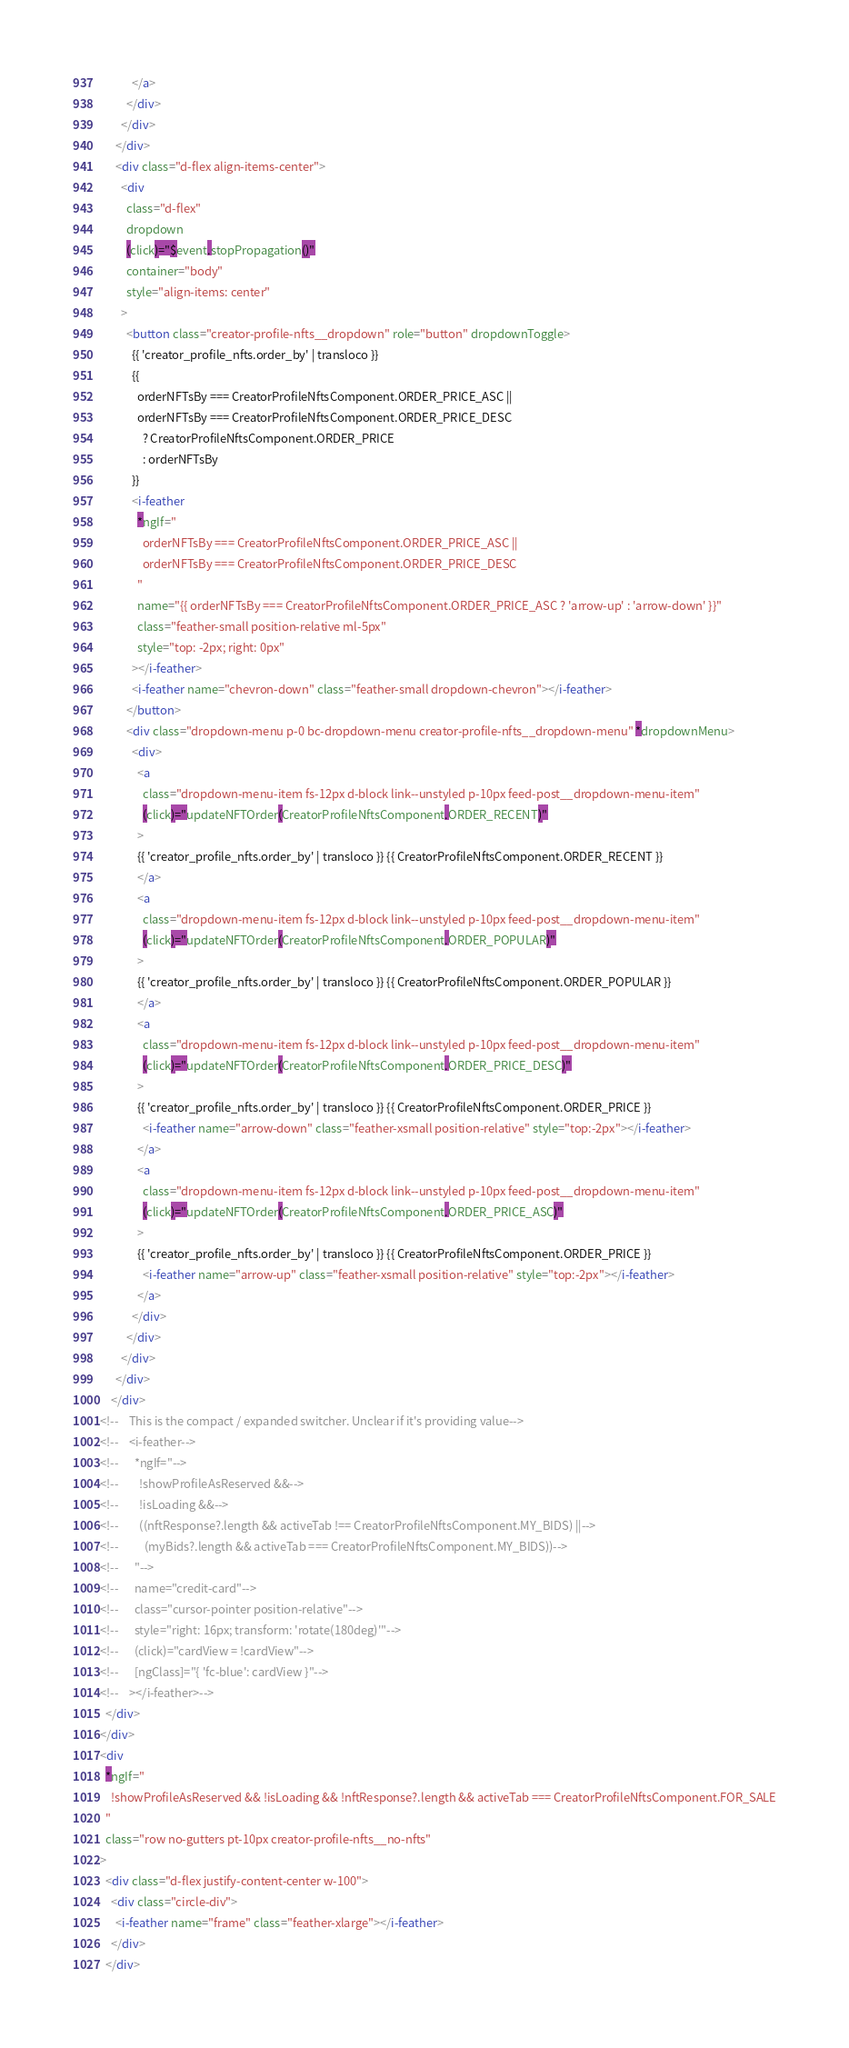Convert code to text. <code><loc_0><loc_0><loc_500><loc_500><_HTML_>            </a>
          </div>
        </div>
      </div>
      <div class="d-flex align-items-center">
        <div
          class="d-flex"
          dropdown
          (click)="$event.stopPropagation()"
          container="body"
          style="align-items: center"
        >
          <button class="creator-profile-nfts__dropdown" role="button" dropdownToggle>
            {{ 'creator_profile_nfts.order_by' | transloco }}
            {{
              orderNFTsBy === CreatorProfileNftsComponent.ORDER_PRICE_ASC ||
              orderNFTsBy === CreatorProfileNftsComponent.ORDER_PRICE_DESC
                ? CreatorProfileNftsComponent.ORDER_PRICE
                : orderNFTsBy
            }}
            <i-feather
              *ngIf="
                orderNFTsBy === CreatorProfileNftsComponent.ORDER_PRICE_ASC ||
                orderNFTsBy === CreatorProfileNftsComponent.ORDER_PRICE_DESC
              "
              name="{{ orderNFTsBy === CreatorProfileNftsComponent.ORDER_PRICE_ASC ? 'arrow-up' : 'arrow-down' }}"
              class="feather-small position-relative ml-5px"
              style="top: -2px; right: 0px"
            ></i-feather>
            <i-feather name="chevron-down" class="feather-small dropdown-chevron"></i-feather>
          </button>
          <div class="dropdown-menu p-0 bc-dropdown-menu creator-profile-nfts__dropdown-menu" *dropdownMenu>
            <div>
              <a
                class="dropdown-menu-item fs-12px d-block link--unstyled p-10px feed-post__dropdown-menu-item"
                (click)="updateNFTOrder(CreatorProfileNftsComponent.ORDER_RECENT)"
              >
              {{ 'creator_profile_nfts.order_by' | transloco }} {{ CreatorProfileNftsComponent.ORDER_RECENT }}
              </a>
              <a
                class="dropdown-menu-item fs-12px d-block link--unstyled p-10px feed-post__dropdown-menu-item"
                (click)="updateNFTOrder(CreatorProfileNftsComponent.ORDER_POPULAR)"
              >
              {{ 'creator_profile_nfts.order_by' | transloco }} {{ CreatorProfileNftsComponent.ORDER_POPULAR }}
              </a>
              <a
                class="dropdown-menu-item fs-12px d-block link--unstyled p-10px feed-post__dropdown-menu-item"
                (click)="updateNFTOrder(CreatorProfileNftsComponent.ORDER_PRICE_DESC)"
              >
              {{ 'creator_profile_nfts.order_by' | transloco }} {{ CreatorProfileNftsComponent.ORDER_PRICE }}
                <i-feather name="arrow-down" class="feather-xsmall position-relative" style="top:-2px"></i-feather>
              </a>
              <a
                class="dropdown-menu-item fs-12px d-block link--unstyled p-10px feed-post__dropdown-menu-item"
                (click)="updateNFTOrder(CreatorProfileNftsComponent.ORDER_PRICE_ASC)"
              >
              {{ 'creator_profile_nfts.order_by' | transloco }} {{ CreatorProfileNftsComponent.ORDER_PRICE }}
                <i-feather name="arrow-up" class="feather-xsmall position-relative" style="top:-2px"></i-feather>
              </a>
            </div>
          </div>
        </div>
      </div>
    </div>
<!--    This is the compact / expanded switcher. Unclear if it's providing value-->
<!--    <i-feather-->
<!--      *ngIf="-->
<!--        !showProfileAsReserved &&-->
<!--        !isLoading &&-->
<!--        ((nftResponse?.length && activeTab !== CreatorProfileNftsComponent.MY_BIDS) ||-->
<!--          (myBids?.length && activeTab === CreatorProfileNftsComponent.MY_BIDS))-->
<!--      "-->
<!--      name="credit-card"-->
<!--      class="cursor-pointer position-relative"-->
<!--      style="right: 16px; transform: 'rotate(180deg)'"-->
<!--      (click)="cardView = !cardView"-->
<!--      [ngClass]="{ 'fc-blue': cardView }"-->
<!--    ></i-feather>-->
  </div>
</div>
<div
  *ngIf="
    !showProfileAsReserved && !isLoading && !nftResponse?.length && activeTab === CreatorProfileNftsComponent.FOR_SALE
  "
  class="row no-gutters pt-10px creator-profile-nfts__no-nfts"
>
  <div class="d-flex justify-content-center w-100">
    <div class="circle-div">
      <i-feather name="frame" class="feather-xlarge"></i-feather>
    </div>
  </div></code> 